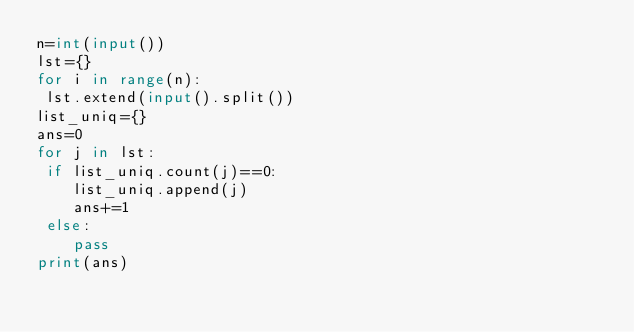Convert code to text. <code><loc_0><loc_0><loc_500><loc_500><_Python_>n=int(input())
lst={}
for i in range(n):
 lst.extend(input().split())
list_uniq={}
ans=0
for j in lst:
 if list_uniq.count(j)==0:
    list_uniq.append(j)
    ans+=1
 else:
    pass
print(ans)</code> 